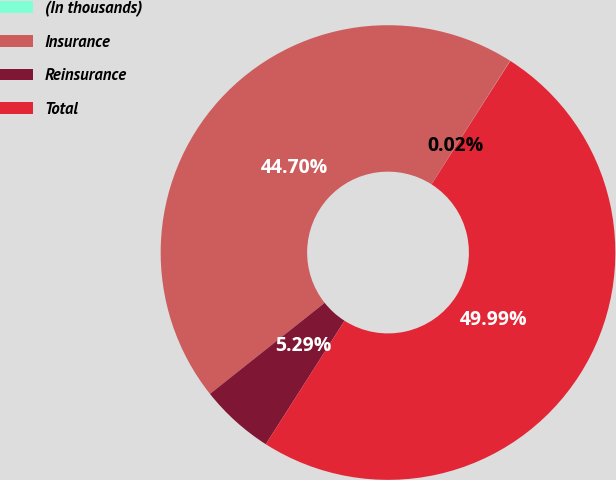<chart> <loc_0><loc_0><loc_500><loc_500><pie_chart><fcel>(In thousands)<fcel>Insurance<fcel>Reinsurance<fcel>Total<nl><fcel>0.02%<fcel>44.7%<fcel>5.29%<fcel>49.99%<nl></chart> 